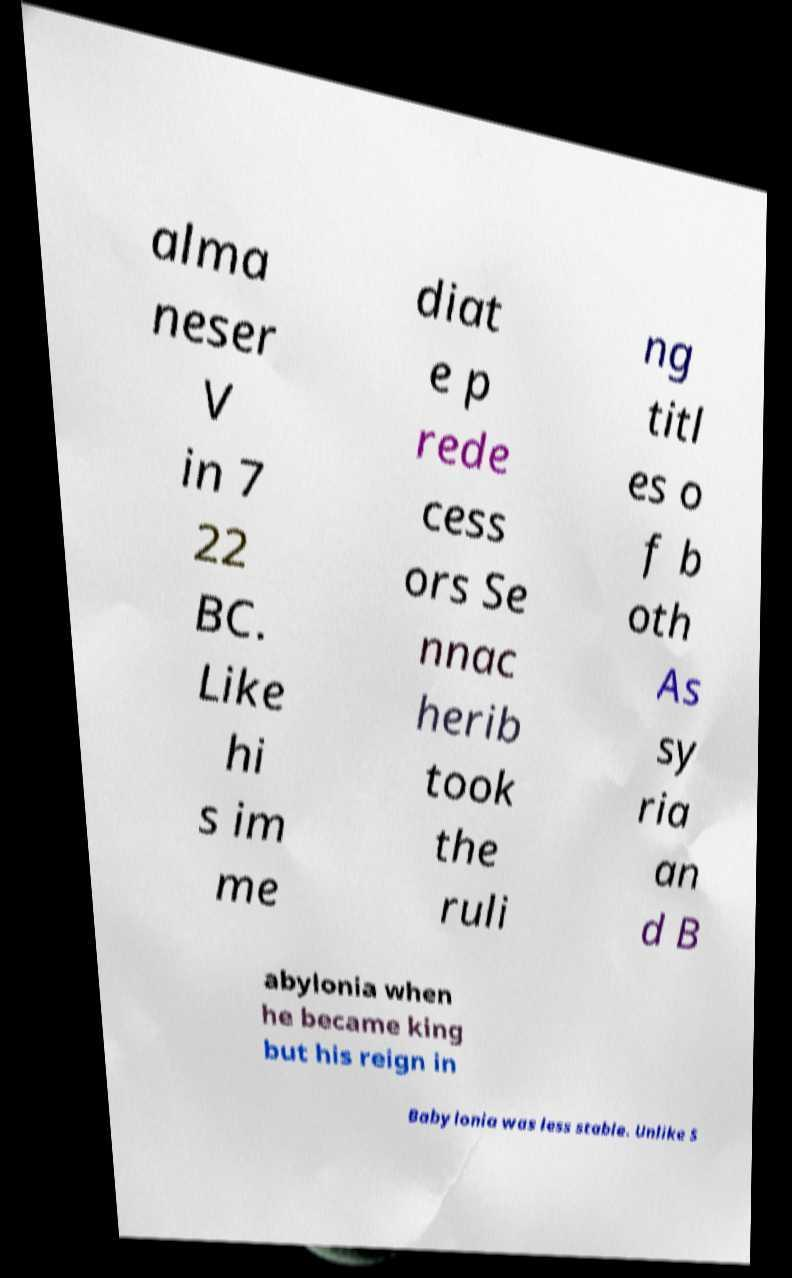Please identify and transcribe the text found in this image. alma neser V in 7 22 BC. Like hi s im me diat e p rede cess ors Se nnac herib took the ruli ng titl es o f b oth As sy ria an d B abylonia when he became king but his reign in Babylonia was less stable. Unlike S 